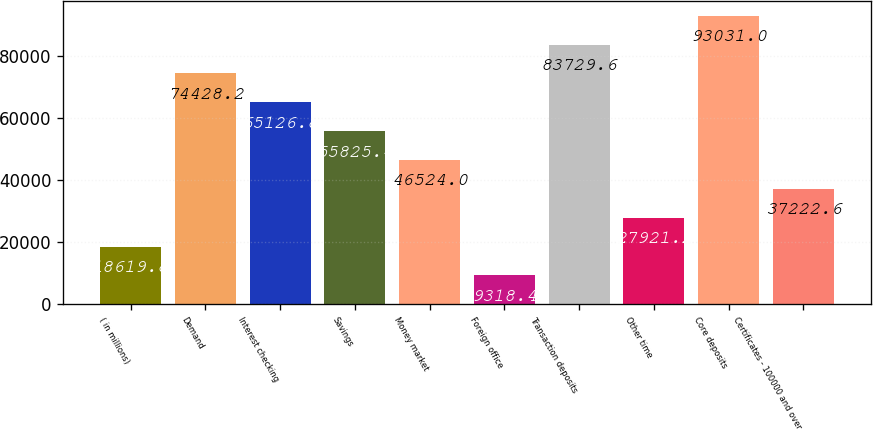Convert chart. <chart><loc_0><loc_0><loc_500><loc_500><bar_chart><fcel>( in millions)<fcel>Demand<fcel>Interest checking<fcel>Savings<fcel>Money market<fcel>Foreign office<fcel>Transaction deposits<fcel>Other time<fcel>Core deposits<fcel>Certificates - 100000 and over<nl><fcel>18619.8<fcel>74428.2<fcel>65126.8<fcel>55825.4<fcel>46524<fcel>9318.4<fcel>83729.6<fcel>27921.2<fcel>93031<fcel>37222.6<nl></chart> 